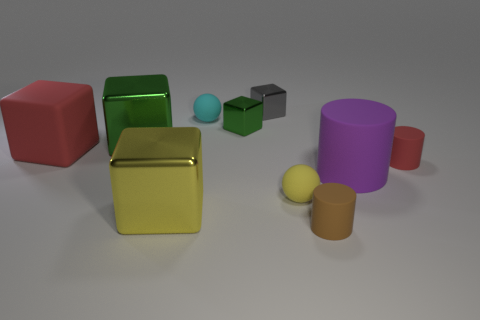Do the red thing left of the brown cylinder and the big purple rubber thing have the same size?
Offer a very short reply. Yes. What number of other objects are the same size as the gray cube?
Provide a succinct answer. 5. Are any small red metal cubes visible?
Make the answer very short. No. There is a red rubber thing that is on the left side of the small yellow ball in front of the big green object; how big is it?
Give a very brief answer. Large. There is a small cylinder behind the big yellow shiny object; is it the same color as the large matte thing left of the tiny green thing?
Your answer should be compact. Yes. The thing that is both to the right of the cyan thing and in front of the yellow rubber sphere is what color?
Your answer should be very brief. Brown. How many other things are there of the same shape as the large green thing?
Provide a succinct answer. 4. There is a rubber cylinder that is the same size as the brown object; what color is it?
Your answer should be compact. Red. The small cylinder that is on the right side of the small brown matte cylinder is what color?
Your answer should be very brief. Red. There is a red rubber object on the left side of the cyan sphere; are there any metal cubes to the right of it?
Provide a succinct answer. Yes. 